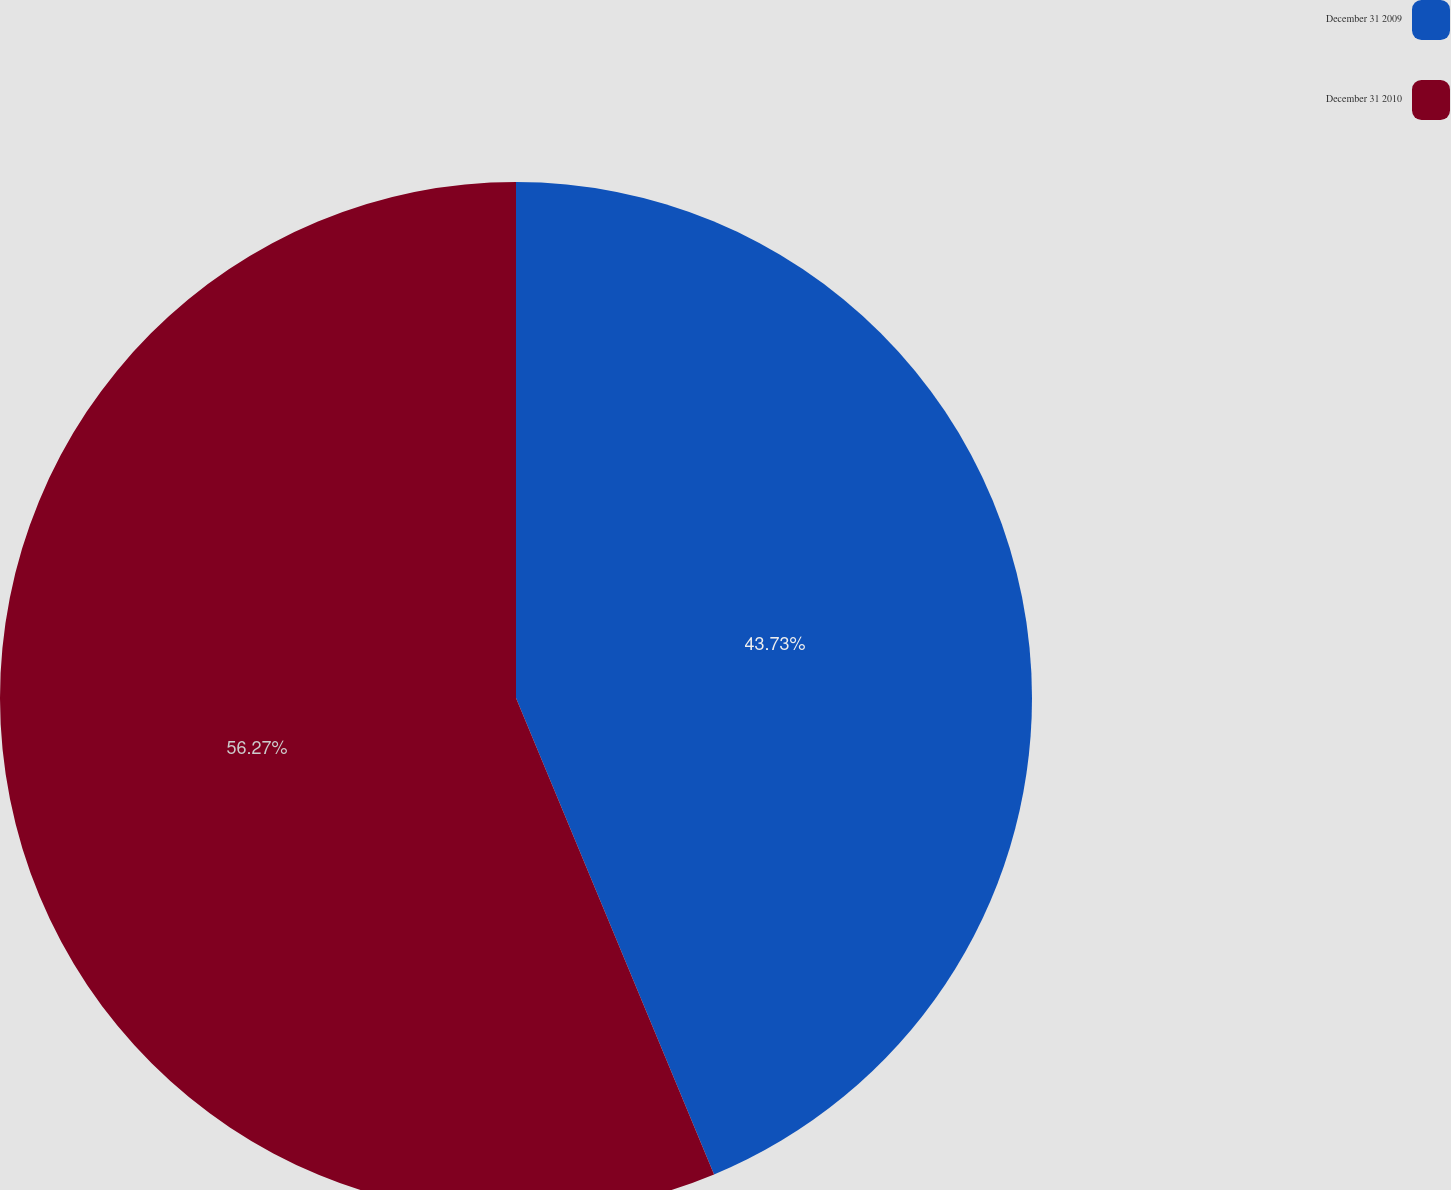<chart> <loc_0><loc_0><loc_500><loc_500><pie_chart><fcel>December 31 2009<fcel>December 31 2010<nl><fcel>43.73%<fcel>56.27%<nl></chart> 